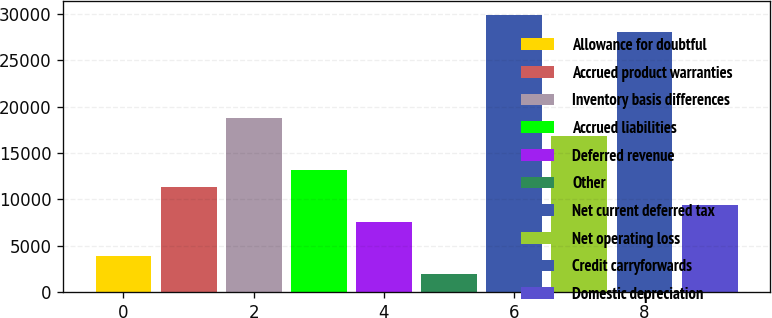Convert chart. <chart><loc_0><loc_0><loc_500><loc_500><bar_chart><fcel>Allowance for doubtful<fcel>Accrued product warranties<fcel>Inventory basis differences<fcel>Accrued liabilities<fcel>Deferred revenue<fcel>Other<fcel>Net current deferred tax<fcel>Net operating loss<fcel>Credit carryforwards<fcel>Domestic depreciation<nl><fcel>3827.4<fcel>11268.2<fcel>18709<fcel>13128.4<fcel>7547.8<fcel>1967.2<fcel>29870.2<fcel>16848.8<fcel>28010<fcel>9408<nl></chart> 